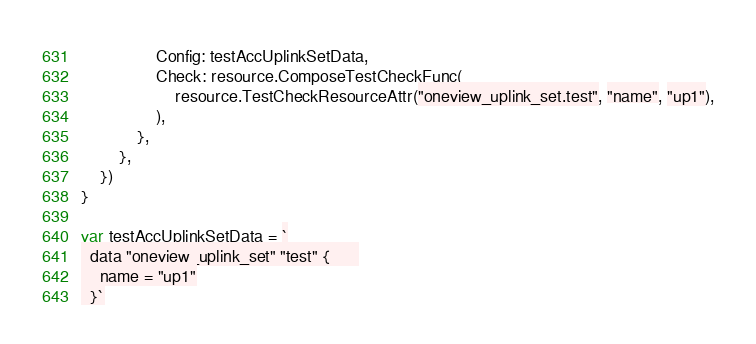<code> <loc_0><loc_0><loc_500><loc_500><_Go_>				Config: testAccUplinkSetData,
				Check: resource.ComposeTestCheckFunc(
					resource.TestCheckResourceAttr("oneview_uplink_set.test", "name", "up1"),
				),
			},
		},
	})
}

var testAccUplinkSetData = `
  data "oneview_uplink_set" "test" {	  
    name = "up1"
  }`
</code> 